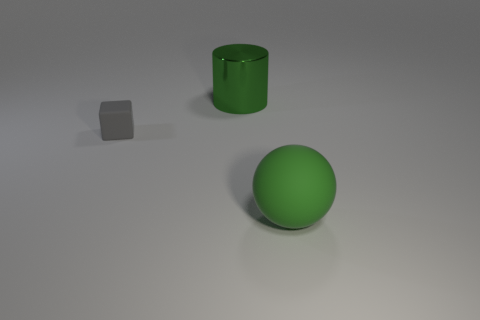Add 3 gray blocks. How many objects exist? 6 Subtract all cylinders. How many objects are left? 2 Add 1 large green metal cylinders. How many large green metal cylinders exist? 2 Subtract 0 yellow cylinders. How many objects are left? 3 Subtract all blue matte cubes. Subtract all tiny cubes. How many objects are left? 2 Add 2 tiny gray objects. How many tiny gray objects are left? 3 